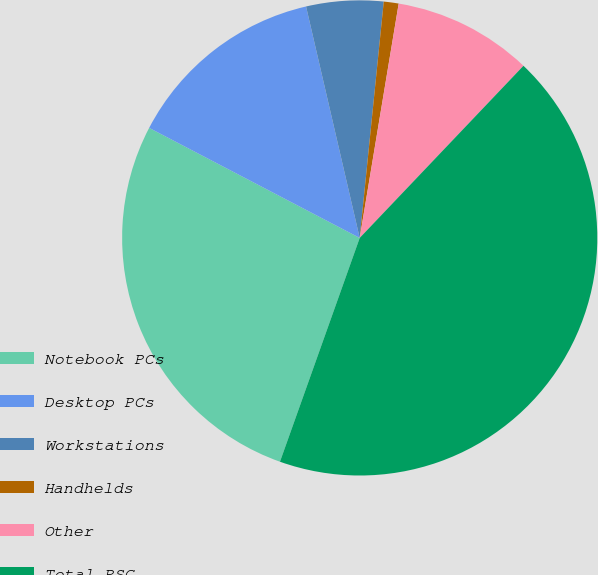Convert chart. <chart><loc_0><loc_0><loc_500><loc_500><pie_chart><fcel>Notebook PCs<fcel>Desktop PCs<fcel>Workstations<fcel>Handhelds<fcel>Other<fcel>Total PSG<nl><fcel>27.22%<fcel>13.71%<fcel>5.24%<fcel>1.01%<fcel>9.48%<fcel>43.35%<nl></chart> 